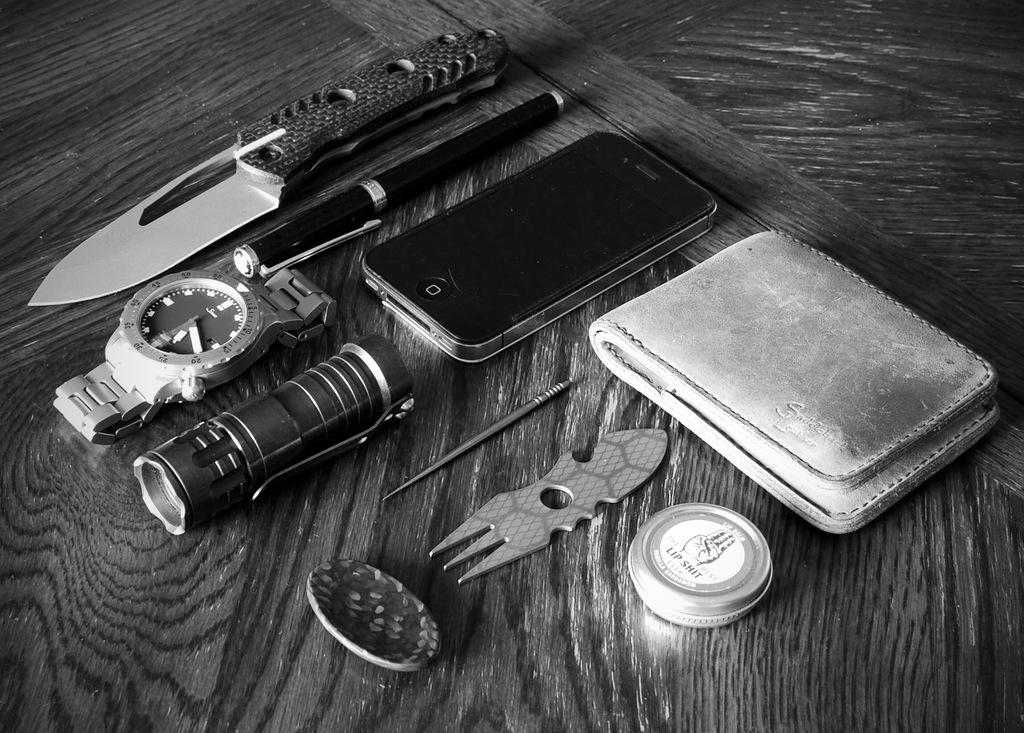What brand name is on the round tin?
Your answer should be compact. Lip shit. 